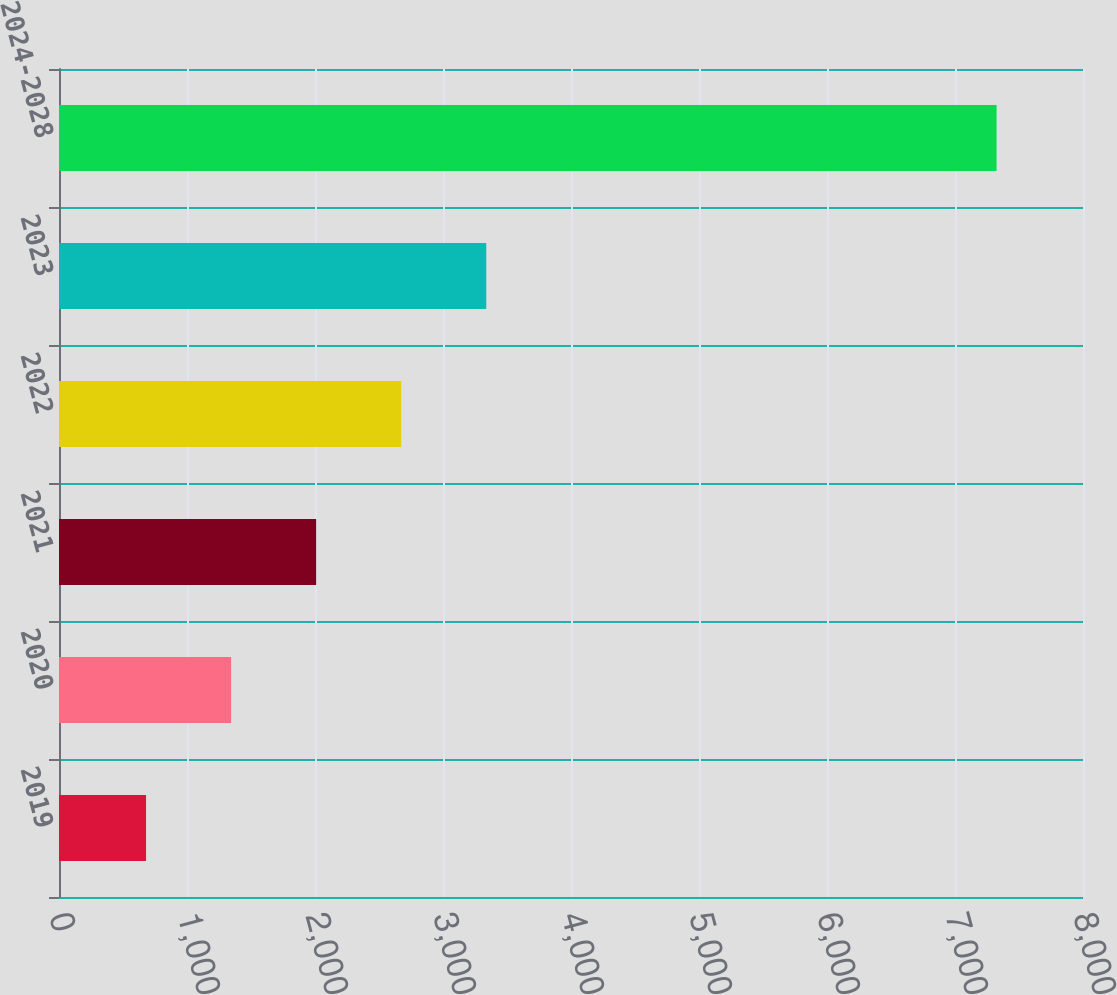<chart> <loc_0><loc_0><loc_500><loc_500><bar_chart><fcel>2019<fcel>2020<fcel>2021<fcel>2022<fcel>2023<fcel>2024-2028<nl><fcel>680<fcel>1344.5<fcel>2009<fcel>2673.5<fcel>3338<fcel>7325<nl></chart> 